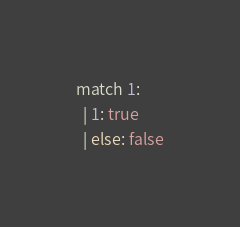<code> <loc_0><loc_0><loc_500><loc_500><_JavaScript_>match 1:
  | 1: true
  | else: false
</code> 